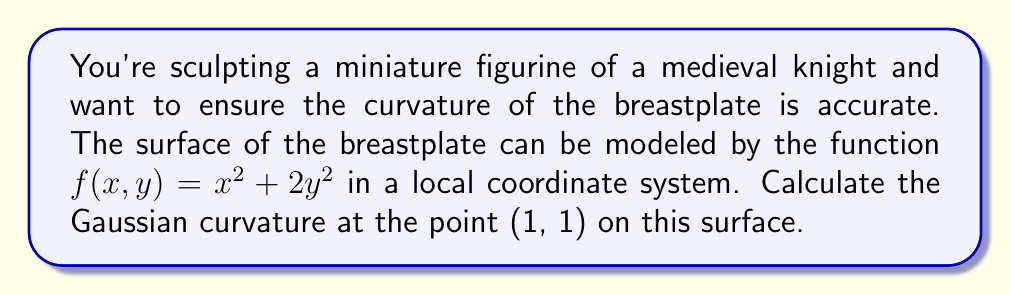Could you help me with this problem? To calculate the Gaussian curvature, we'll follow these steps:

1) The Gaussian curvature K is given by:
   $$K = \frac{LN - M^2}{EG - F^2}$$
   where L, M, N are coefficients of the second fundamental form, and E, F, G are coefficients of the first fundamental form.

2) For a surface given by $z = f(x,y)$, we have:
   $$E = 1 + f_x^2$$
   $$F = f_x f_y$$
   $$G = 1 + f_y^2$$
   $$L = \frac{f_{xx}}{\sqrt{1 + f_x^2 + f_y^2}}$$
   $$M = \frac{f_{xy}}{\sqrt{1 + f_x^2 + f_y^2}}$$
   $$N = \frac{f_{yy}}{\sqrt{1 + f_x^2 + f_y^2}}$$

3) Calculate partial derivatives:
   $f_x = 2x$, $f_y = 4y$
   $f_{xx} = 2$, $f_{xy} = 0$, $f_{yy} = 4$

4) At point (1, 1):
   $f_x = 2$, $f_y = 4$
   $f_{xx} = 2$, $f_{xy} = 0$, $f_{yy} = 4$

5) Calculate E, F, G:
   $E = 1 + (2)^2 = 5$
   $F = 2 \cdot 4 = 8$
   $G = 1 + (4)^2 = 17$

6) Calculate L, M, N:
   $L = \frac{2}{\sqrt{1 + 2^2 + 4^2}} = \frac{2}{\sqrt{21}}$
   $M = 0$
   $N = \frac{4}{\sqrt{21}}$

7) Now we can calculate K:
   $$K = \frac{(\frac{2}{\sqrt{21}})(\frac{4}{\sqrt{21}}) - 0^2}{5 \cdot 17 - 8^2} = \frac{8/21}{85 - 64} = \frac{8}{21 \cdot 21} = \frac{8}{441}$$
Answer: $\frac{8}{441}$ 